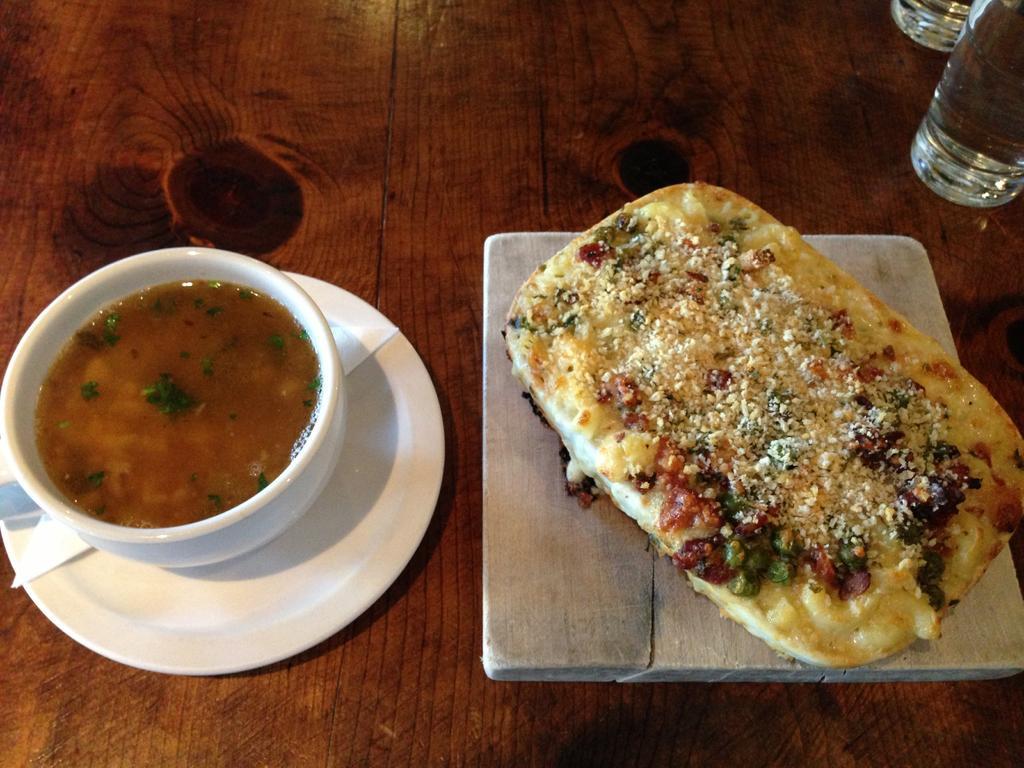Describe this image in one or two sentences. In this image we can see some food item in the bowl and there is plate and a paper under the bowl and a food item on the wooden object and there are glass objects on the table. 